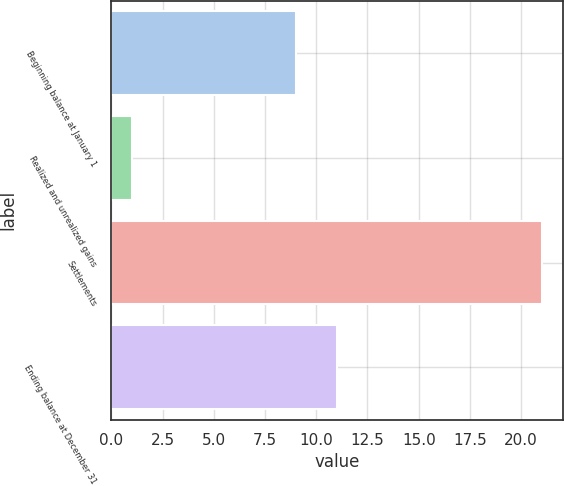Convert chart to OTSL. <chart><loc_0><loc_0><loc_500><loc_500><bar_chart><fcel>Beginning balance at January 1<fcel>Realized and unrealized gains<fcel>Settlements<fcel>Ending balance at December 31<nl><fcel>9<fcel>1<fcel>21<fcel>11<nl></chart> 